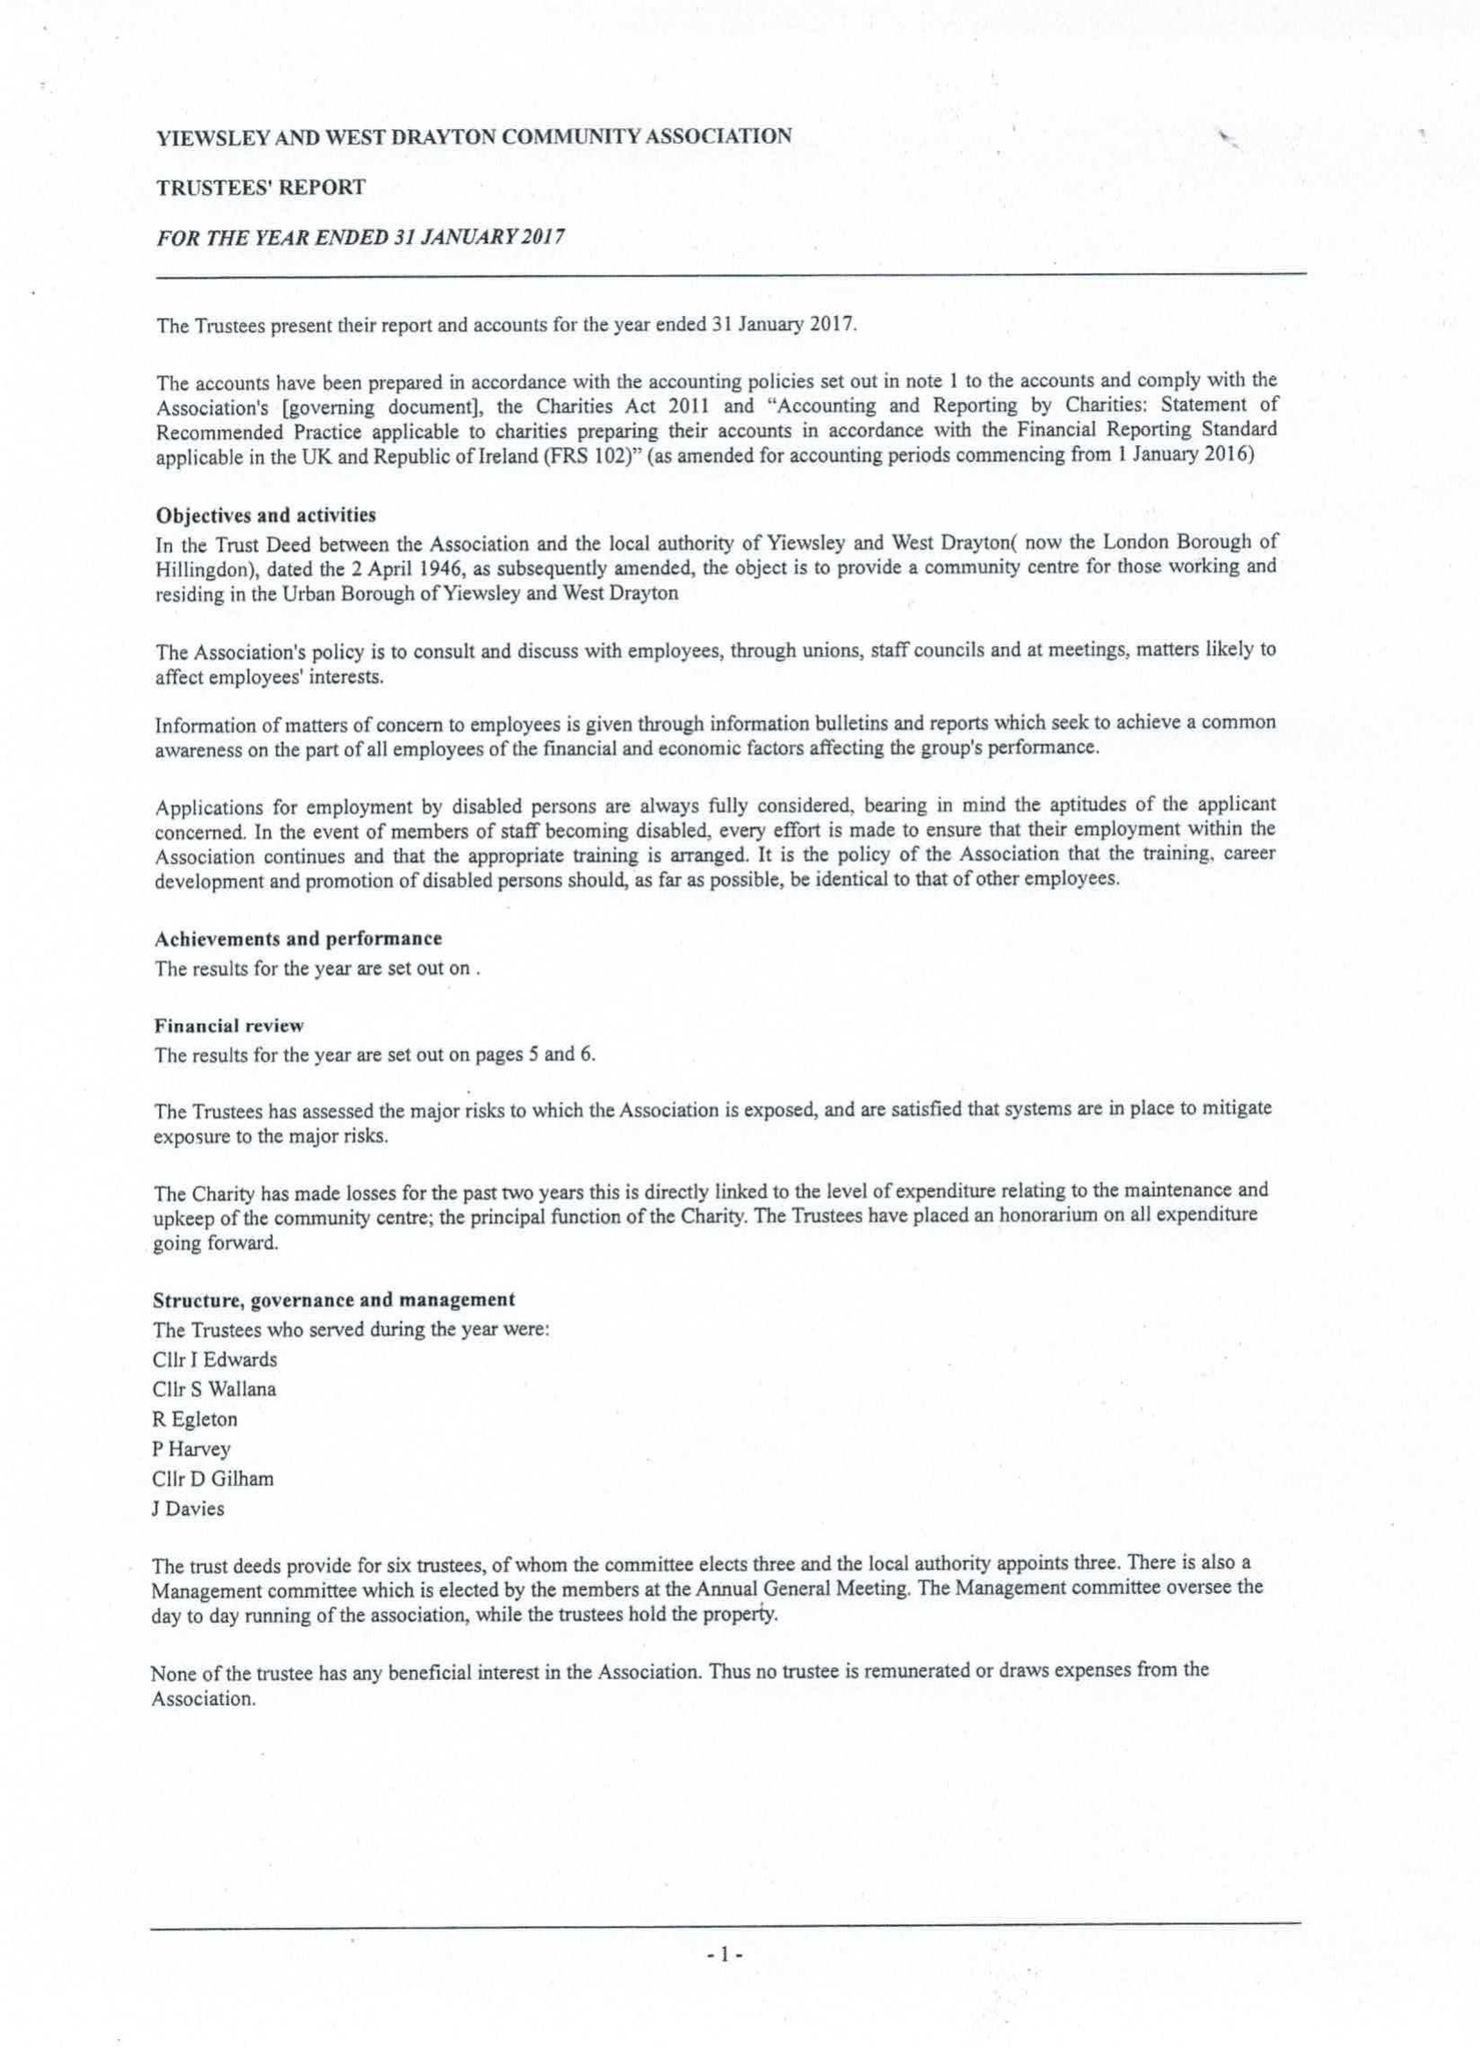What is the value for the charity_name?
Answer the question using a single word or phrase. Yiewsley and West Drayton Community Association 